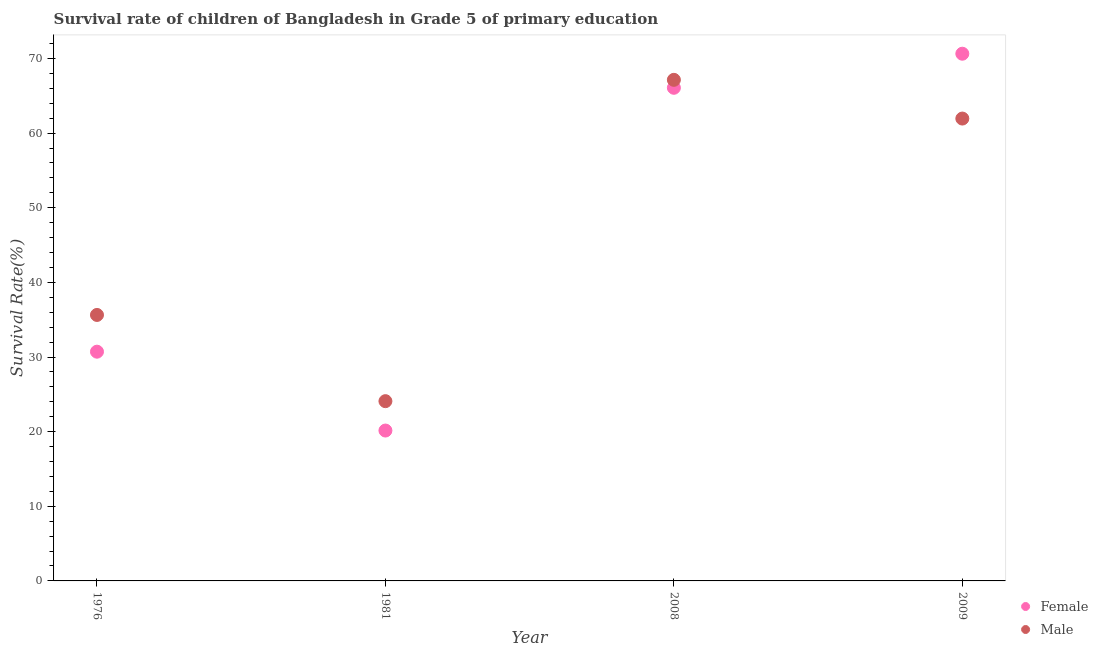How many different coloured dotlines are there?
Ensure brevity in your answer.  2. Is the number of dotlines equal to the number of legend labels?
Provide a succinct answer. Yes. What is the survival rate of female students in primary education in 1976?
Keep it short and to the point. 30.71. Across all years, what is the maximum survival rate of male students in primary education?
Your answer should be very brief. 67.14. Across all years, what is the minimum survival rate of male students in primary education?
Provide a succinct answer. 24.09. In which year was the survival rate of female students in primary education maximum?
Make the answer very short. 2009. In which year was the survival rate of female students in primary education minimum?
Give a very brief answer. 1981. What is the total survival rate of female students in primary education in the graph?
Your answer should be very brief. 187.57. What is the difference between the survival rate of female students in primary education in 1976 and that in 2008?
Give a very brief answer. -35.36. What is the difference between the survival rate of female students in primary education in 1976 and the survival rate of male students in primary education in 2009?
Provide a succinct answer. -31.24. What is the average survival rate of female students in primary education per year?
Give a very brief answer. 46.89. In the year 1976, what is the difference between the survival rate of female students in primary education and survival rate of male students in primary education?
Make the answer very short. -4.92. What is the ratio of the survival rate of male students in primary education in 1976 to that in 2009?
Your answer should be very brief. 0.58. Is the difference between the survival rate of male students in primary education in 1976 and 2009 greater than the difference between the survival rate of female students in primary education in 1976 and 2009?
Offer a very short reply. Yes. What is the difference between the highest and the second highest survival rate of female students in primary education?
Offer a terse response. 4.57. What is the difference between the highest and the lowest survival rate of female students in primary education?
Provide a succinct answer. 50.49. Is the survival rate of female students in primary education strictly less than the survival rate of male students in primary education over the years?
Your answer should be very brief. No. How many dotlines are there?
Your answer should be compact. 2. Are the values on the major ticks of Y-axis written in scientific E-notation?
Your response must be concise. No. Does the graph contain grids?
Offer a very short reply. No. What is the title of the graph?
Keep it short and to the point. Survival rate of children of Bangladesh in Grade 5 of primary education. Does "Secondary Education" appear as one of the legend labels in the graph?
Give a very brief answer. No. What is the label or title of the X-axis?
Keep it short and to the point. Year. What is the label or title of the Y-axis?
Your response must be concise. Survival Rate(%). What is the Survival Rate(%) in Female in 1976?
Offer a very short reply. 30.71. What is the Survival Rate(%) in Male in 1976?
Your answer should be very brief. 35.64. What is the Survival Rate(%) of Female in 1981?
Ensure brevity in your answer.  20.15. What is the Survival Rate(%) in Male in 1981?
Provide a succinct answer. 24.09. What is the Survival Rate(%) in Female in 2008?
Provide a succinct answer. 66.07. What is the Survival Rate(%) in Male in 2008?
Provide a succinct answer. 67.14. What is the Survival Rate(%) of Female in 2009?
Provide a short and direct response. 70.64. What is the Survival Rate(%) of Male in 2009?
Offer a very short reply. 61.95. Across all years, what is the maximum Survival Rate(%) in Female?
Your response must be concise. 70.64. Across all years, what is the maximum Survival Rate(%) in Male?
Provide a short and direct response. 67.14. Across all years, what is the minimum Survival Rate(%) in Female?
Ensure brevity in your answer.  20.15. Across all years, what is the minimum Survival Rate(%) in Male?
Provide a succinct answer. 24.09. What is the total Survival Rate(%) in Female in the graph?
Your response must be concise. 187.57. What is the total Survival Rate(%) in Male in the graph?
Provide a succinct answer. 188.81. What is the difference between the Survival Rate(%) of Female in 1976 and that in 1981?
Your answer should be very brief. 10.57. What is the difference between the Survival Rate(%) of Male in 1976 and that in 1981?
Your response must be concise. 11.55. What is the difference between the Survival Rate(%) in Female in 1976 and that in 2008?
Your answer should be very brief. -35.36. What is the difference between the Survival Rate(%) of Male in 1976 and that in 2008?
Your response must be concise. -31.5. What is the difference between the Survival Rate(%) of Female in 1976 and that in 2009?
Offer a terse response. -39.92. What is the difference between the Survival Rate(%) in Male in 1976 and that in 2009?
Your response must be concise. -26.31. What is the difference between the Survival Rate(%) of Female in 1981 and that in 2008?
Make the answer very short. -45.92. What is the difference between the Survival Rate(%) in Male in 1981 and that in 2008?
Keep it short and to the point. -43.05. What is the difference between the Survival Rate(%) of Female in 1981 and that in 2009?
Provide a short and direct response. -50.49. What is the difference between the Survival Rate(%) in Male in 1981 and that in 2009?
Make the answer very short. -37.86. What is the difference between the Survival Rate(%) of Female in 2008 and that in 2009?
Provide a short and direct response. -4.57. What is the difference between the Survival Rate(%) in Male in 2008 and that in 2009?
Keep it short and to the point. 5.19. What is the difference between the Survival Rate(%) of Female in 1976 and the Survival Rate(%) of Male in 1981?
Ensure brevity in your answer.  6.63. What is the difference between the Survival Rate(%) of Female in 1976 and the Survival Rate(%) of Male in 2008?
Your answer should be very brief. -36.42. What is the difference between the Survival Rate(%) of Female in 1976 and the Survival Rate(%) of Male in 2009?
Give a very brief answer. -31.24. What is the difference between the Survival Rate(%) in Female in 1981 and the Survival Rate(%) in Male in 2008?
Provide a succinct answer. -46.99. What is the difference between the Survival Rate(%) in Female in 1981 and the Survival Rate(%) in Male in 2009?
Provide a succinct answer. -41.8. What is the difference between the Survival Rate(%) in Female in 2008 and the Survival Rate(%) in Male in 2009?
Make the answer very short. 4.12. What is the average Survival Rate(%) in Female per year?
Make the answer very short. 46.89. What is the average Survival Rate(%) of Male per year?
Provide a succinct answer. 47.2. In the year 1976, what is the difference between the Survival Rate(%) of Female and Survival Rate(%) of Male?
Provide a short and direct response. -4.92. In the year 1981, what is the difference between the Survival Rate(%) in Female and Survival Rate(%) in Male?
Make the answer very short. -3.94. In the year 2008, what is the difference between the Survival Rate(%) in Female and Survival Rate(%) in Male?
Give a very brief answer. -1.07. In the year 2009, what is the difference between the Survival Rate(%) in Female and Survival Rate(%) in Male?
Offer a very short reply. 8.69. What is the ratio of the Survival Rate(%) of Female in 1976 to that in 1981?
Give a very brief answer. 1.52. What is the ratio of the Survival Rate(%) in Male in 1976 to that in 1981?
Keep it short and to the point. 1.48. What is the ratio of the Survival Rate(%) of Female in 1976 to that in 2008?
Make the answer very short. 0.46. What is the ratio of the Survival Rate(%) of Male in 1976 to that in 2008?
Give a very brief answer. 0.53. What is the ratio of the Survival Rate(%) of Female in 1976 to that in 2009?
Your response must be concise. 0.43. What is the ratio of the Survival Rate(%) of Male in 1976 to that in 2009?
Make the answer very short. 0.58. What is the ratio of the Survival Rate(%) of Female in 1981 to that in 2008?
Make the answer very short. 0.3. What is the ratio of the Survival Rate(%) of Male in 1981 to that in 2008?
Make the answer very short. 0.36. What is the ratio of the Survival Rate(%) of Female in 1981 to that in 2009?
Give a very brief answer. 0.29. What is the ratio of the Survival Rate(%) in Male in 1981 to that in 2009?
Provide a short and direct response. 0.39. What is the ratio of the Survival Rate(%) of Female in 2008 to that in 2009?
Give a very brief answer. 0.94. What is the ratio of the Survival Rate(%) in Male in 2008 to that in 2009?
Provide a short and direct response. 1.08. What is the difference between the highest and the second highest Survival Rate(%) in Female?
Give a very brief answer. 4.57. What is the difference between the highest and the second highest Survival Rate(%) in Male?
Offer a very short reply. 5.19. What is the difference between the highest and the lowest Survival Rate(%) of Female?
Make the answer very short. 50.49. What is the difference between the highest and the lowest Survival Rate(%) in Male?
Your response must be concise. 43.05. 